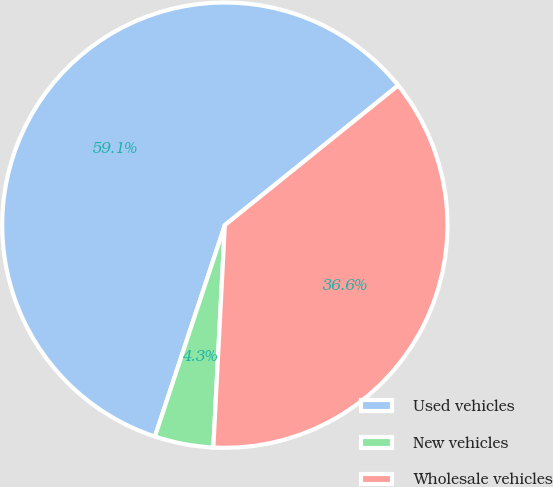<chart> <loc_0><loc_0><loc_500><loc_500><pie_chart><fcel>Used vehicles<fcel>New vehicles<fcel>Wholesale vehicles<nl><fcel>59.12%<fcel>4.26%<fcel>36.62%<nl></chart> 